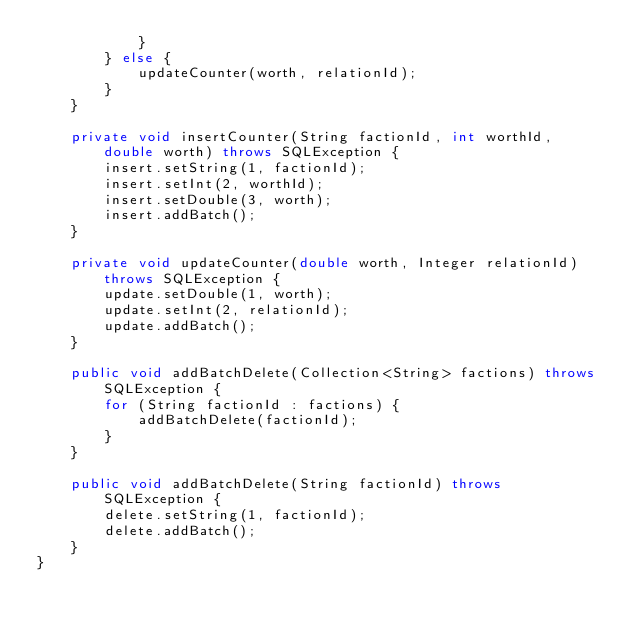<code> <loc_0><loc_0><loc_500><loc_500><_Java_>            }
        } else {
            updateCounter(worth, relationId);
        }
    }

    private void insertCounter(String factionId, int worthId, double worth) throws SQLException {
        insert.setString(1, factionId);
        insert.setInt(2, worthId);
        insert.setDouble(3, worth);
        insert.addBatch();
    }

    private void updateCounter(double worth, Integer relationId) throws SQLException {
        update.setDouble(1, worth);
        update.setInt(2, relationId);
        update.addBatch();
    }

    public void addBatchDelete(Collection<String> factions) throws SQLException {
        for (String factionId : factions) {
            addBatchDelete(factionId);
        }
    }

    public void addBatchDelete(String factionId) throws SQLException {
        delete.setString(1, factionId);
        delete.addBatch();
    }
}
</code> 